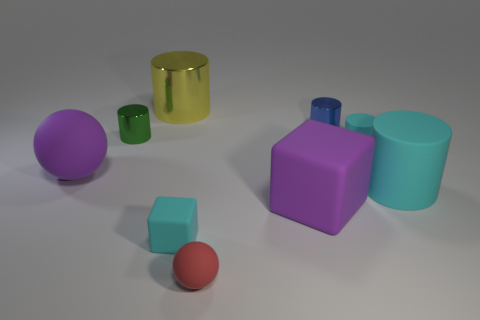Subtract 1 cylinders. How many cylinders are left? 4 Subtract all gray cylinders. Subtract all cyan balls. How many cylinders are left? 5 Subtract all cylinders. How many objects are left? 4 Subtract all small gray matte things. Subtract all large rubber blocks. How many objects are left? 8 Add 7 blocks. How many blocks are left? 9 Add 1 tiny green shiny cylinders. How many tiny green shiny cylinders exist? 2 Subtract 0 red blocks. How many objects are left? 9 